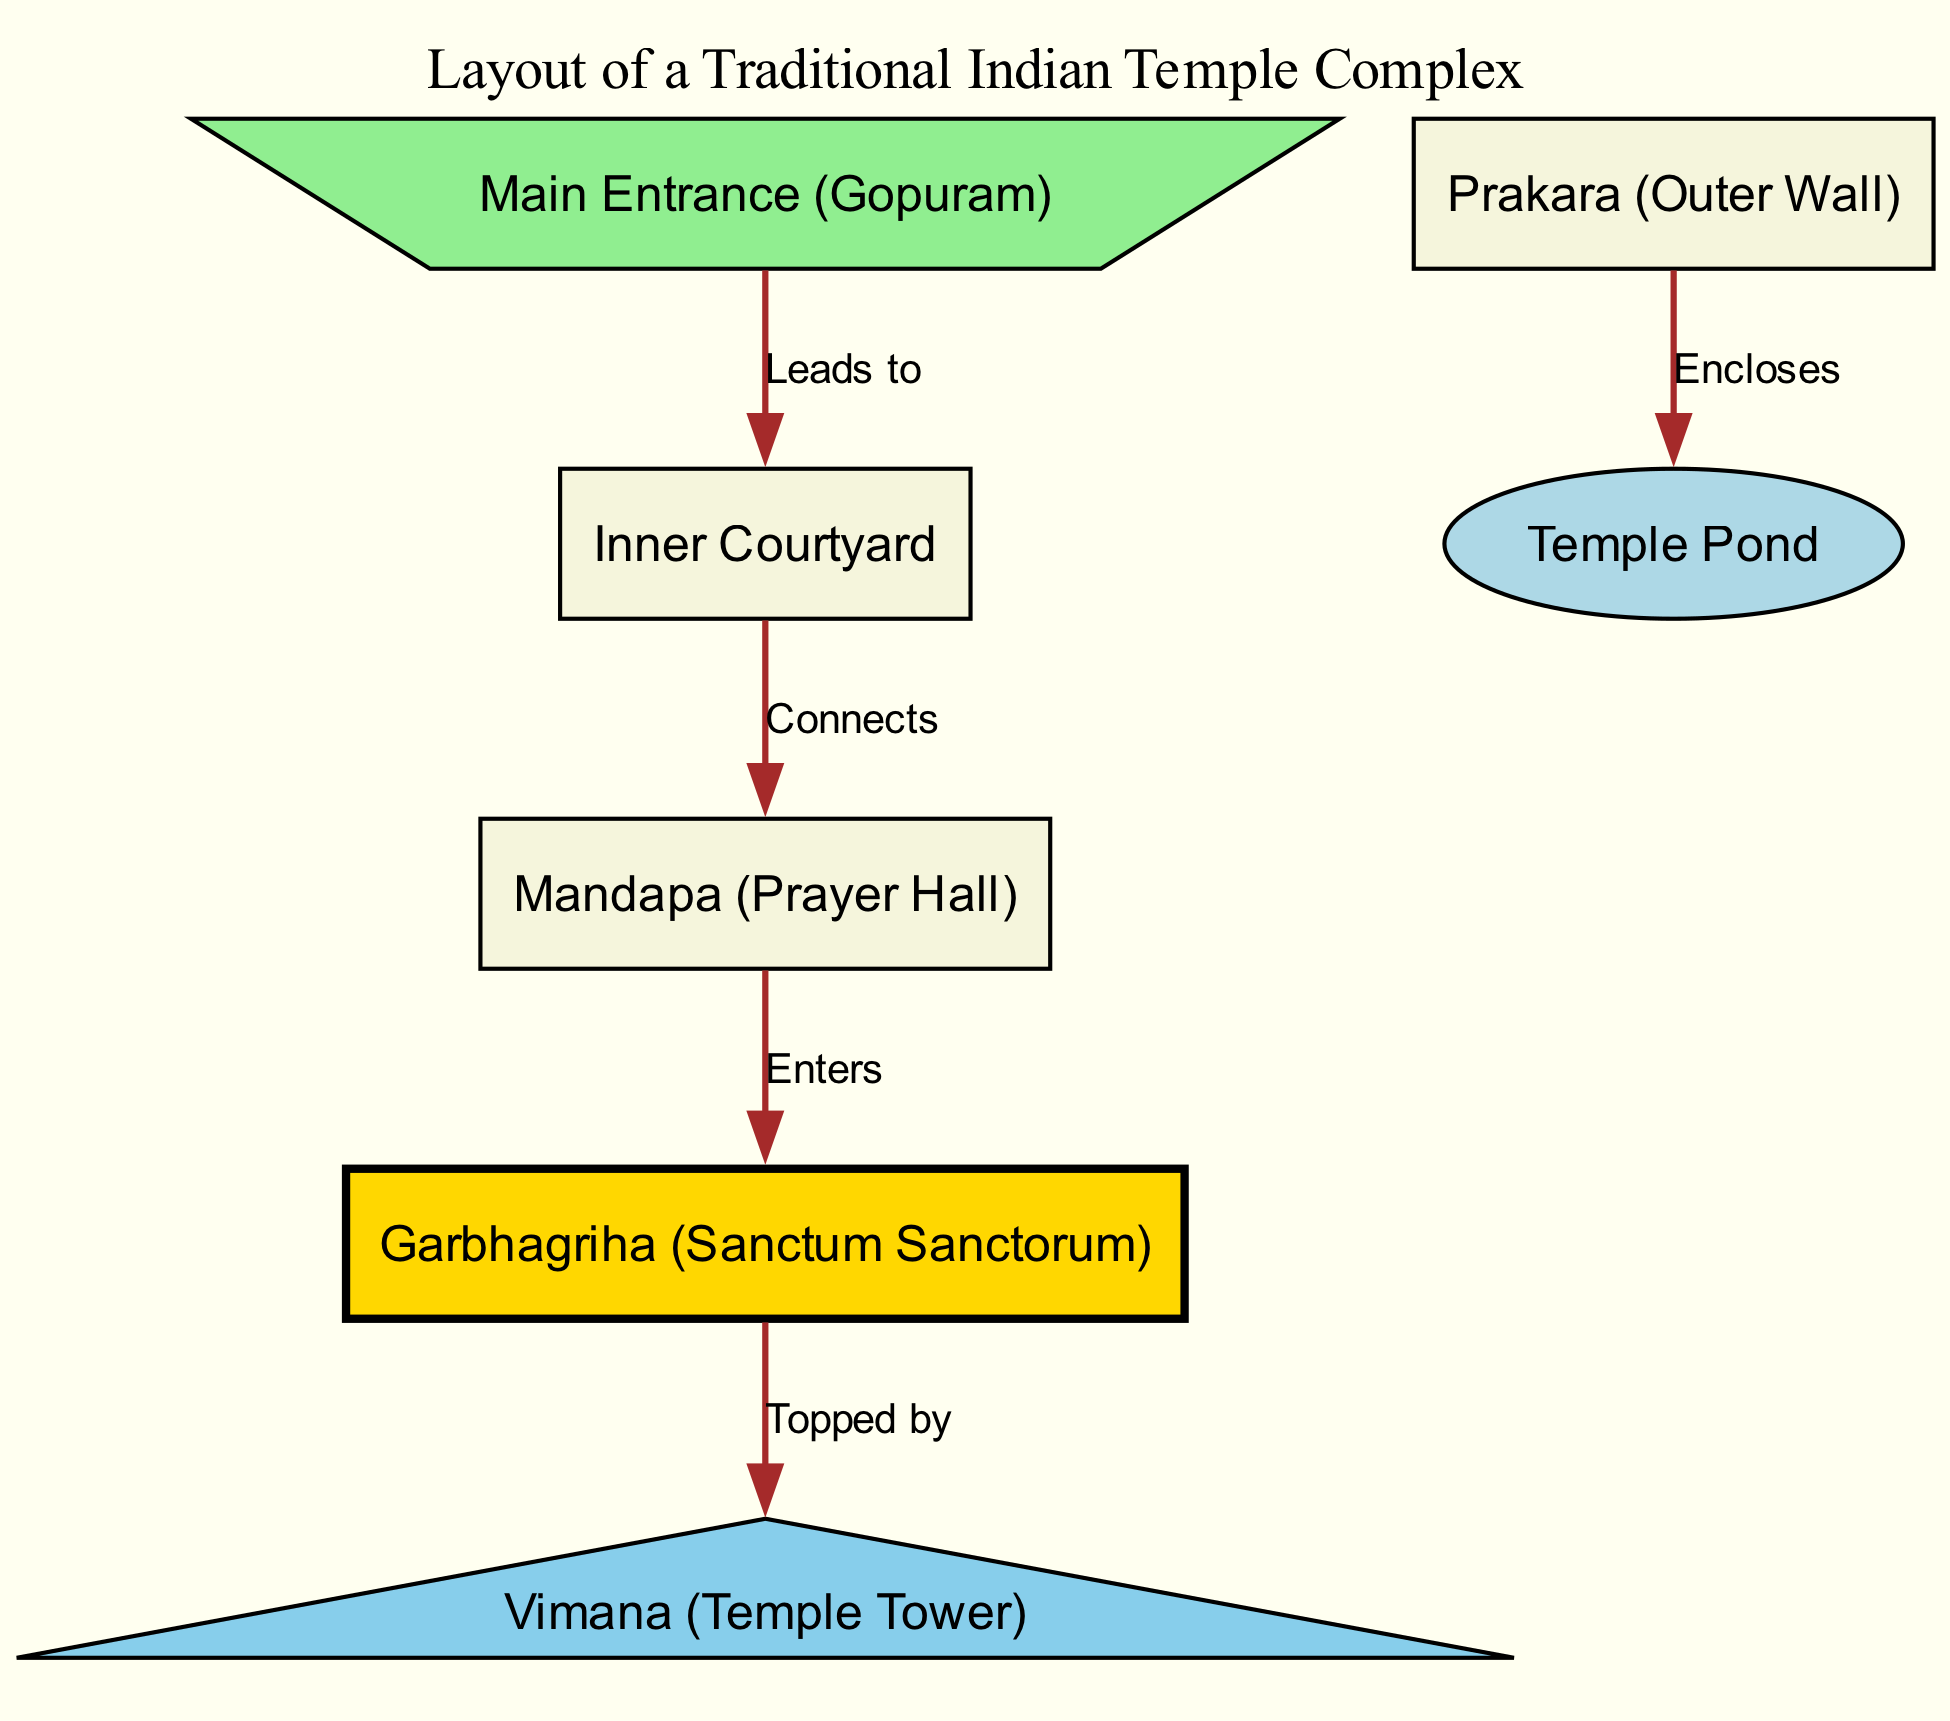What is the first structure one encounters at the temple complex? The diagram indicates that the Main Entrance (Gopuram) is the first structure as it leads to the Inner Courtyard.
Answer: Main Entrance (Gopuram) How many nodes are present in the diagram? By counting the nodes listed in the data, there are a total of 7 nodes representing different elements of the temple complex.
Answer: 7 What does the Mandapa connect to? The edge from the Inner Courtyard to the Mandapa indicates that it connects directly to the Prayer Hall.
Answer: Prayer Hall What structure is directly above the Garbhagriha? According to the diagram, the Vimana is directly above the Garbhagriha, as indicated by the arrow depicting the relationship.
Answer: Vimana What does the Prakara enclose? The edge from the Prakara points to the Temple Pond, indicating that it encloses this feature.
Answer: Temple Pond What is the color of the Garbhagriha node? The node representing the Garbhagriha is depicted in gold according to the defined styles in the diagram.
Answer: Gold Which structure is labeled as the Prayer Hall? The Mandapa is the structure labeled as the Prayer Hall in the diagram.
Answer: Mandapa How does one access the Garbhagriha? Access is established through the Mandapa, as indicated by the connection leading from the Mandapa to the Garbhagriha in the diagram.
Answer: Through Mandapa What relationship exists between the entrance and the courtyard? The diagram shows that the entrance leads to the courtyard, which clearly denotes a directional relationship between them.
Answer: Leads to 